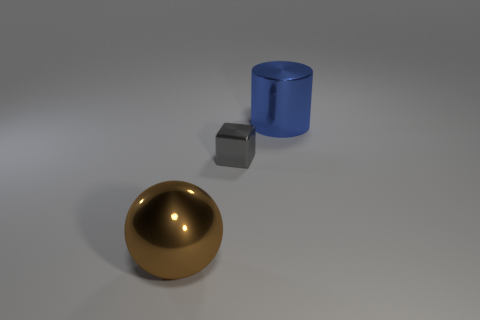Are there any big brown metal things that are on the left side of the large object right of the large thing that is in front of the big blue shiny cylinder? Yes, there is a large brown metal sphere positioned on the left side of the image, relative to the large blue cylinder located more towards the center. 